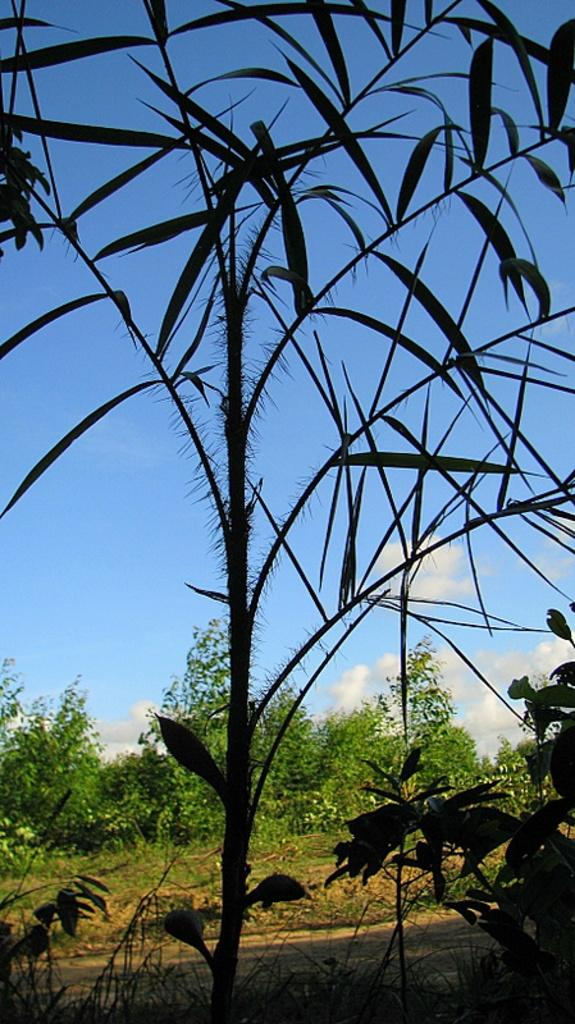What is the main subject in the middle of the image? There is a plant in the middle of the image. Can you describe the plant's appearance? The plant has small leaves. What can be seen at the top of the image? The sky is visible at the top of the image. What type of vegetation is visible in the background of the image? There are trees in the background of the image. What type of ground is visible in the image? There is sand and grass on the ground in the image. Where is the market located in the image? There is no market present in the image. Can you describe the crowd in the image? There is no crowd present in the image. 